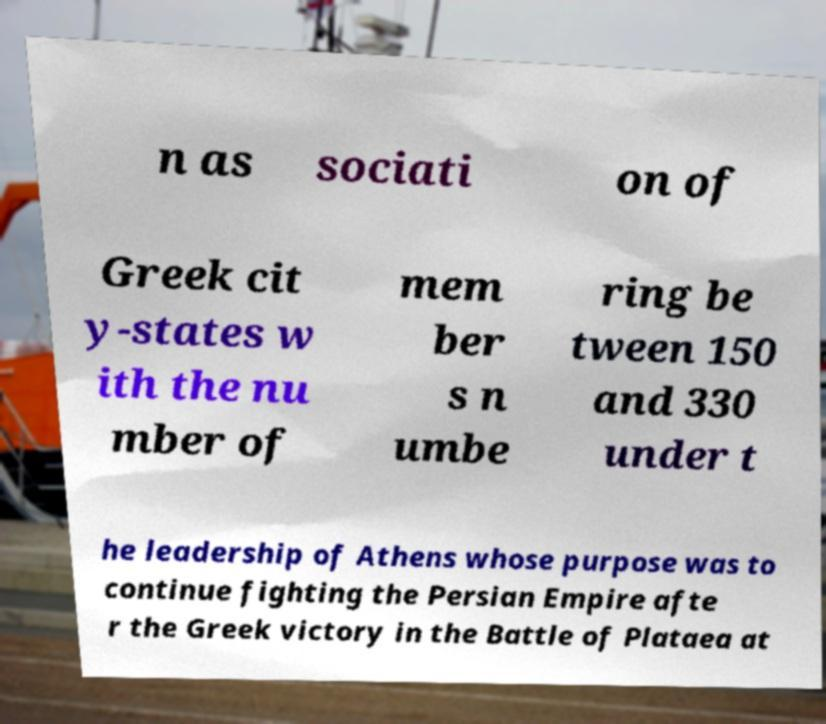Can you read and provide the text displayed in the image?This photo seems to have some interesting text. Can you extract and type it out for me? n as sociati on of Greek cit y-states w ith the nu mber of mem ber s n umbe ring be tween 150 and 330 under t he leadership of Athens whose purpose was to continue fighting the Persian Empire afte r the Greek victory in the Battle of Plataea at 